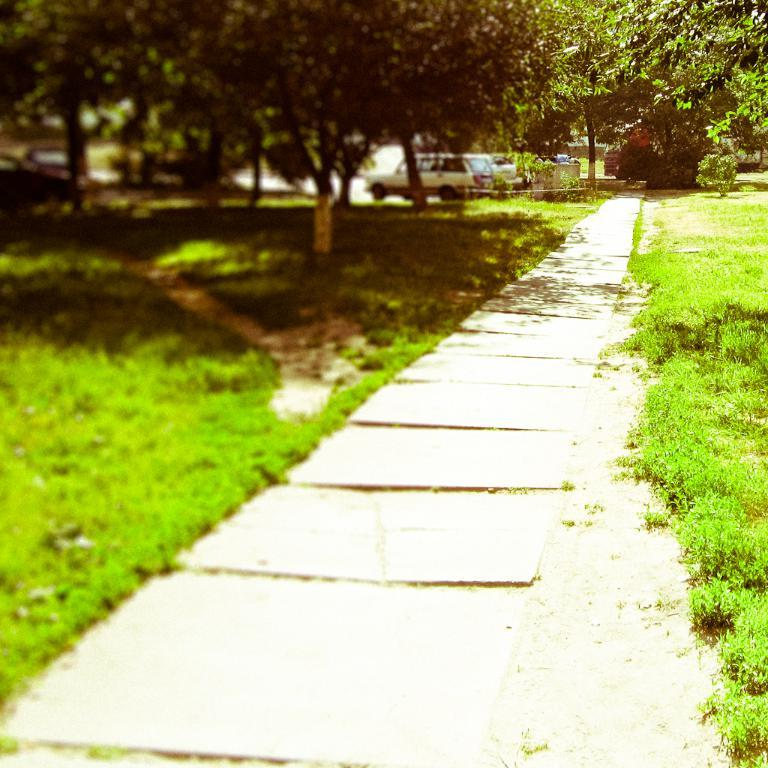What type of surface can be seen in the image? There is a pathway in the image. What type of natural environment is visible in the image? There are grasslands and trees in the image. What can be seen parked in the image? There are vehicles parked in the image. Can you describe the quality of the image on the left side? The left side of the image is slightly blurred. What type of yam is being harvested in the image? There is no yam present in the image; it features a pathway, grasslands, trees, and vehicles. How does the image twist and turn in the image? The image does not twist or turn; it is a still photograph. 